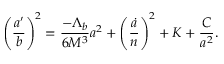Convert formula to latex. <formula><loc_0><loc_0><loc_500><loc_500>\left ( \frac { a ^ { \prime } } { b } \right ) ^ { 2 } = \frac { - \Lambda _ { b } } { 6 M ^ { 3 } } a ^ { 2 } + \left ( \frac { \dot { a } } { n } \right ) ^ { 2 } + K + \frac { C } { a ^ { 2 } } .</formula> 